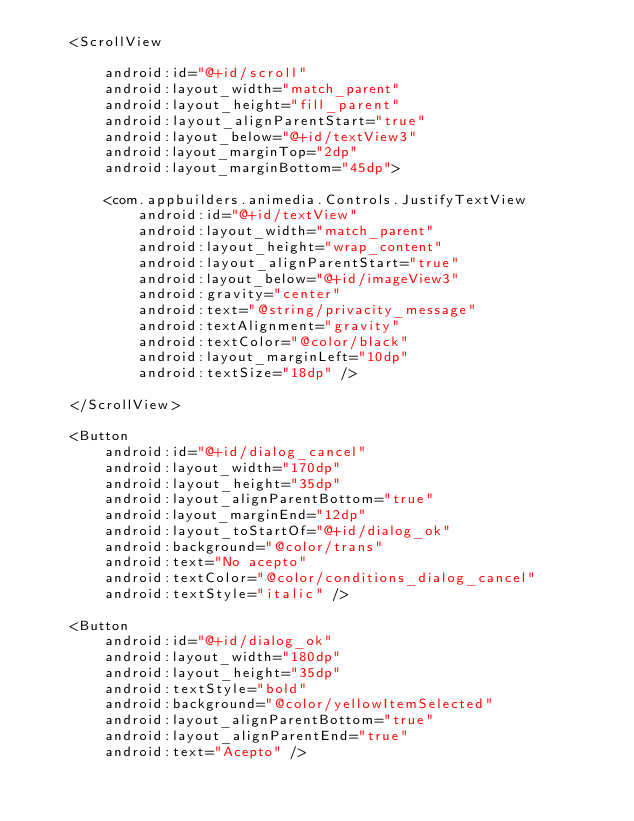<code> <loc_0><loc_0><loc_500><loc_500><_XML_>    <ScrollView

        android:id="@+id/scroll"
        android:layout_width="match_parent"
        android:layout_height="fill_parent"
        android:layout_alignParentStart="true"
        android:layout_below="@+id/textView3"
        android:layout_marginTop="2dp"
        android:layout_marginBottom="45dp">

        <com.appbuilders.animedia.Controls.JustifyTextView
            android:id="@+id/textView"
            android:layout_width="match_parent"
            android:layout_height="wrap_content"
            android:layout_alignParentStart="true"
            android:layout_below="@+id/imageView3"
            android:gravity="center"
            android:text="@string/privacity_message"
            android:textAlignment="gravity"
            android:textColor="@color/black"
            android:layout_marginLeft="10dp"
            android:textSize="18dp" />

    </ScrollView>

    <Button
        android:id="@+id/dialog_cancel"
        android:layout_width="170dp"
        android:layout_height="35dp"
        android:layout_alignParentBottom="true"
        android:layout_marginEnd="12dp"
        android:layout_toStartOf="@+id/dialog_ok"
        android:background="@color/trans"
        android:text="No acepto"
        android:textColor="@color/conditions_dialog_cancel"
        android:textStyle="italic" />

    <Button
        android:id="@+id/dialog_ok"
        android:layout_width="180dp"
        android:layout_height="35dp"
        android:textStyle="bold"
        android:background="@color/yellowItemSelected"
        android:layout_alignParentBottom="true"
        android:layout_alignParentEnd="true"
        android:text="Acepto" />
</code> 